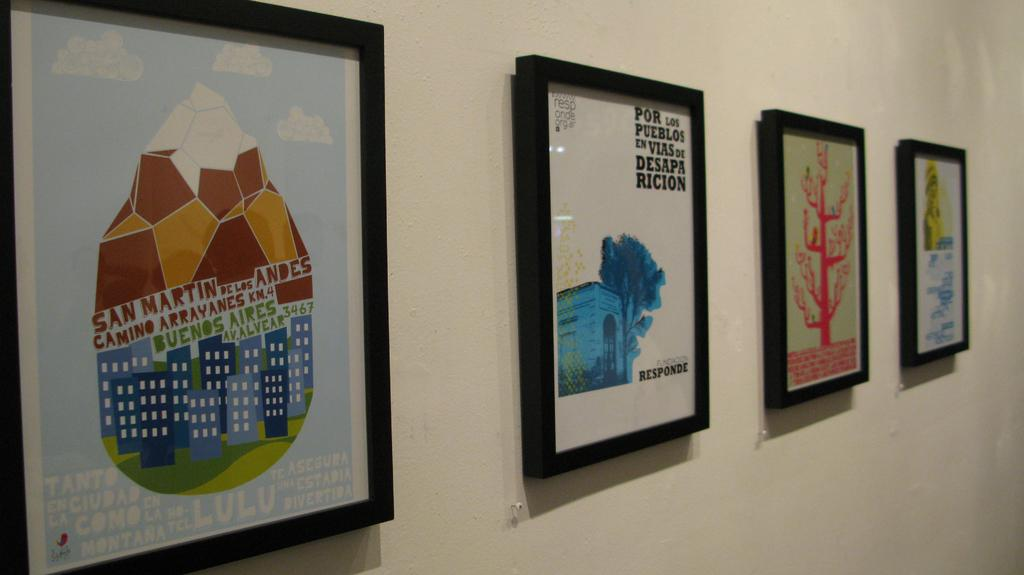<image>
Summarize the visual content of the image. A picture with the message por los pueblos en vias de desapa ricion. 